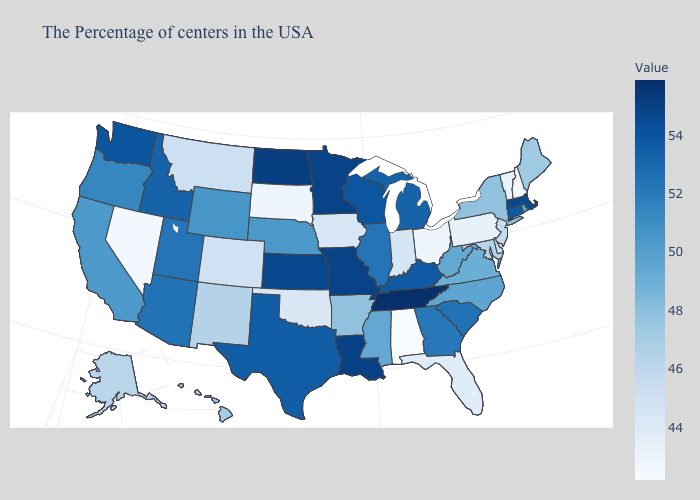Among the states that border Alabama , which have the highest value?
Quick response, please. Tennessee. Does Connecticut have the lowest value in the Northeast?
Answer briefly. No. Among the states that border Illinois , which have the highest value?
Short answer required. Missouri. Does Alabama have the lowest value in the South?
Be succinct. Yes. Among the states that border Kentucky , does Tennessee have the highest value?
Keep it brief. Yes. 